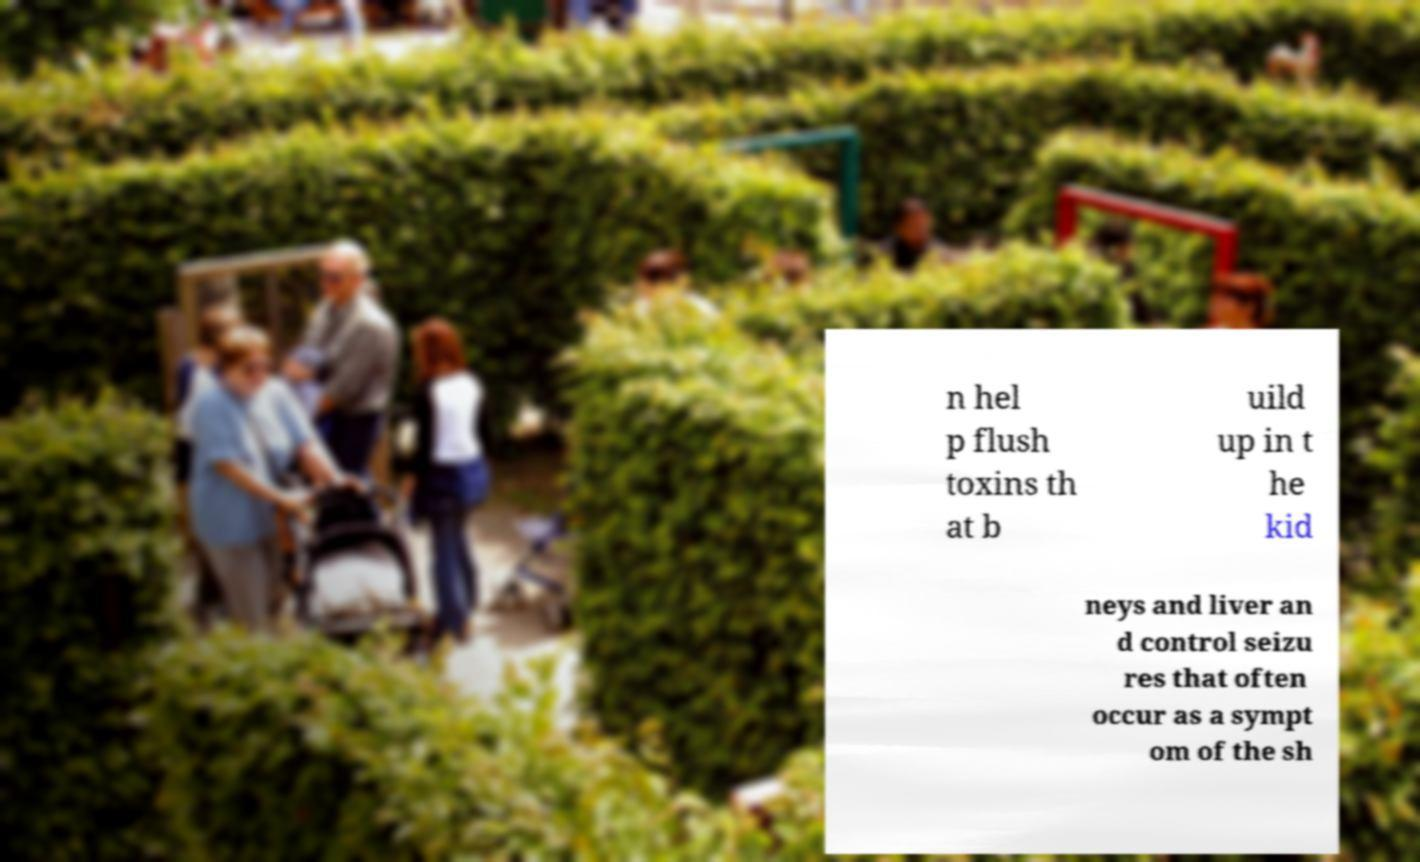What messages or text are displayed in this image? I need them in a readable, typed format. n hel p flush toxins th at b uild up in t he kid neys and liver an d control seizu res that often occur as a sympt om of the sh 